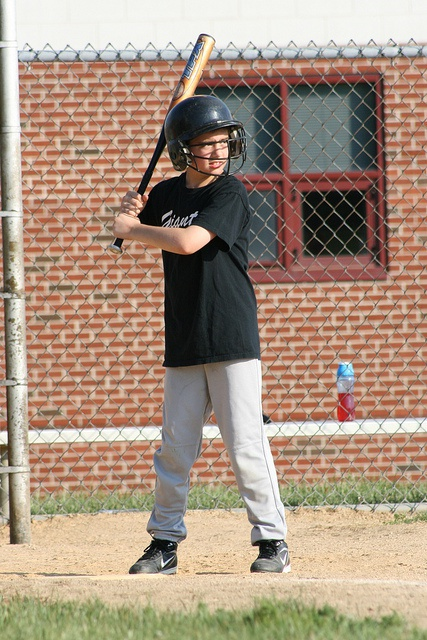Describe the objects in this image and their specific colors. I can see people in gray, black, lightgray, and darkgray tones, baseball bat in gray, black, khaki, and beige tones, and bottle in gray, darkgray, brown, and lightblue tones in this image. 